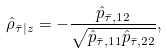<formula> <loc_0><loc_0><loc_500><loc_500>\hat { \rho } _ { \bar { \tau } | z } = - \frac { \hat { p } _ { \bar { \tau } , 1 2 } } { \sqrt { \hat { p } _ { \bar { \tau } , 1 1 } \hat { p } _ { \bar { \tau } , 2 2 } } } ,</formula> 